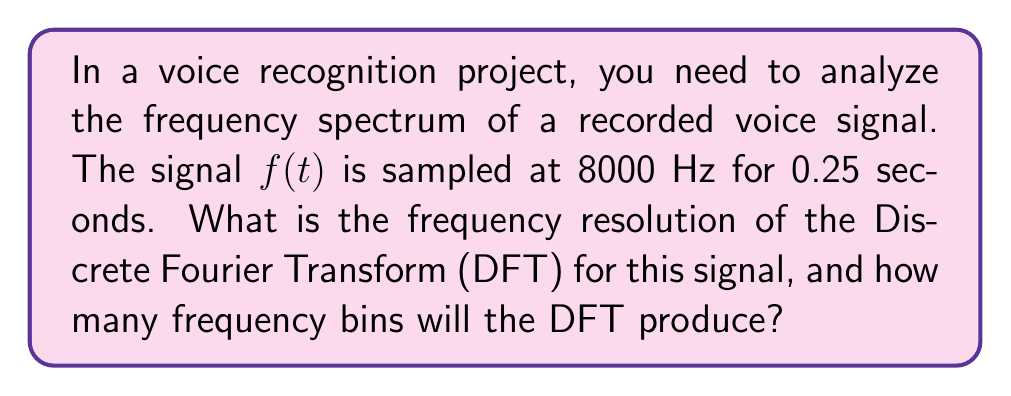Provide a solution to this math problem. To solve this problem, we need to follow these steps:

1. Calculate the total number of samples:
   Sampling rate = 8000 Hz
   Duration = 0.25 seconds
   Number of samples = $8000 \times 0.25 = 2000$ samples

2. Determine the frequency resolution:
   The frequency resolution $\Delta f$ is given by:
   $$\Delta f = \frac{f_s}{N}$$
   Where $f_s$ is the sampling frequency and $N$ is the number of samples.

   $$\Delta f = \frac{8000}{2000} = 4 \text{ Hz}$$

3. Calculate the number of frequency bins:
   The DFT produces $N/2 + 1$ unique frequency bins for real-valued signals, where $N$ is the number of samples.

   Number of frequency bins = $2000/2 + 1 = 1001$

Therefore, the frequency resolution is 4 Hz, and the DFT will produce 1001 frequency bins.
Answer: 4 Hz resolution, 1001 frequency bins 